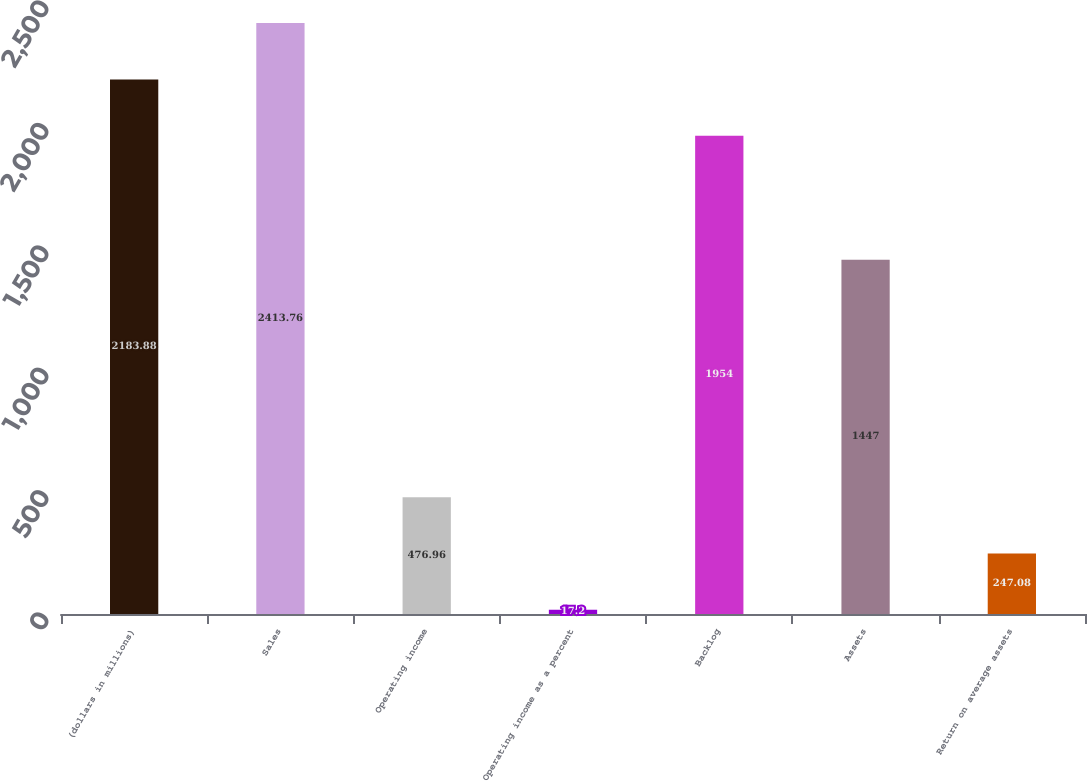Convert chart to OTSL. <chart><loc_0><loc_0><loc_500><loc_500><bar_chart><fcel>(dollars in millions)<fcel>Sales<fcel>Operating income<fcel>Operating income as a percent<fcel>Backlog<fcel>Assets<fcel>Return on average assets<nl><fcel>2183.88<fcel>2413.76<fcel>476.96<fcel>17.2<fcel>1954<fcel>1447<fcel>247.08<nl></chart> 